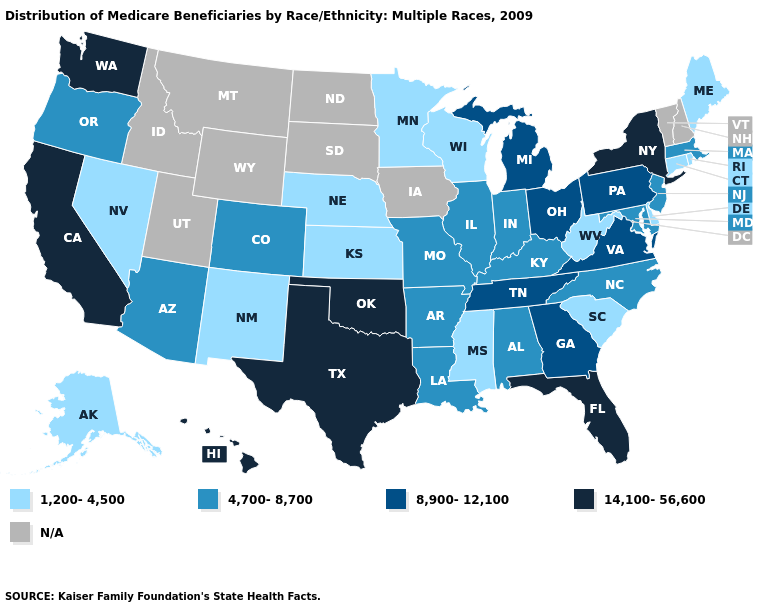What is the value of Washington?
Write a very short answer. 14,100-56,600. Does Texas have the highest value in the USA?
Concise answer only. Yes. Name the states that have a value in the range 1,200-4,500?
Answer briefly. Alaska, Connecticut, Delaware, Kansas, Maine, Minnesota, Mississippi, Nebraska, Nevada, New Mexico, Rhode Island, South Carolina, West Virginia, Wisconsin. Does Indiana have the highest value in the MidWest?
Short answer required. No. How many symbols are there in the legend?
Be succinct. 5. Is the legend a continuous bar?
Be succinct. No. What is the value of Wyoming?
Write a very short answer. N/A. Does South Carolina have the lowest value in the USA?
Keep it brief. Yes. Which states have the highest value in the USA?
Write a very short answer. California, Florida, Hawaii, New York, Oklahoma, Texas, Washington. What is the highest value in the South ?
Give a very brief answer. 14,100-56,600. What is the highest value in the USA?
Concise answer only. 14,100-56,600. Does California have the highest value in the USA?
Keep it brief. Yes. What is the highest value in the Northeast ?
Answer briefly. 14,100-56,600. Does New Mexico have the lowest value in the West?
Quick response, please. Yes. 